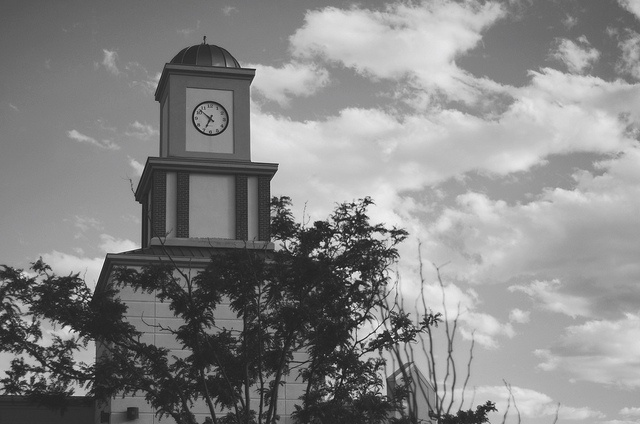Describe the objects in this image and their specific colors. I can see a clock in gray, black, and darkgray tones in this image. 